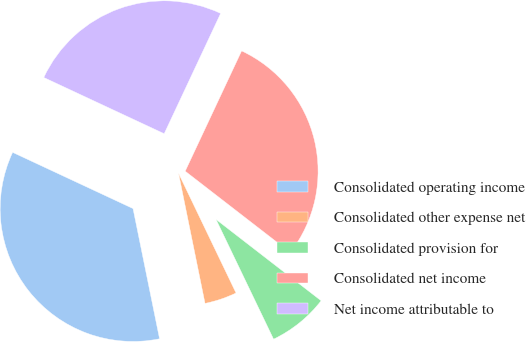<chart> <loc_0><loc_0><loc_500><loc_500><pie_chart><fcel>Consolidated operating income<fcel>Consolidated other expense net<fcel>Consolidated provision for<fcel>Consolidated net income<fcel>Net income attributable to<nl><fcel>35.15%<fcel>3.93%<fcel>7.39%<fcel>28.5%<fcel>25.03%<nl></chart> 